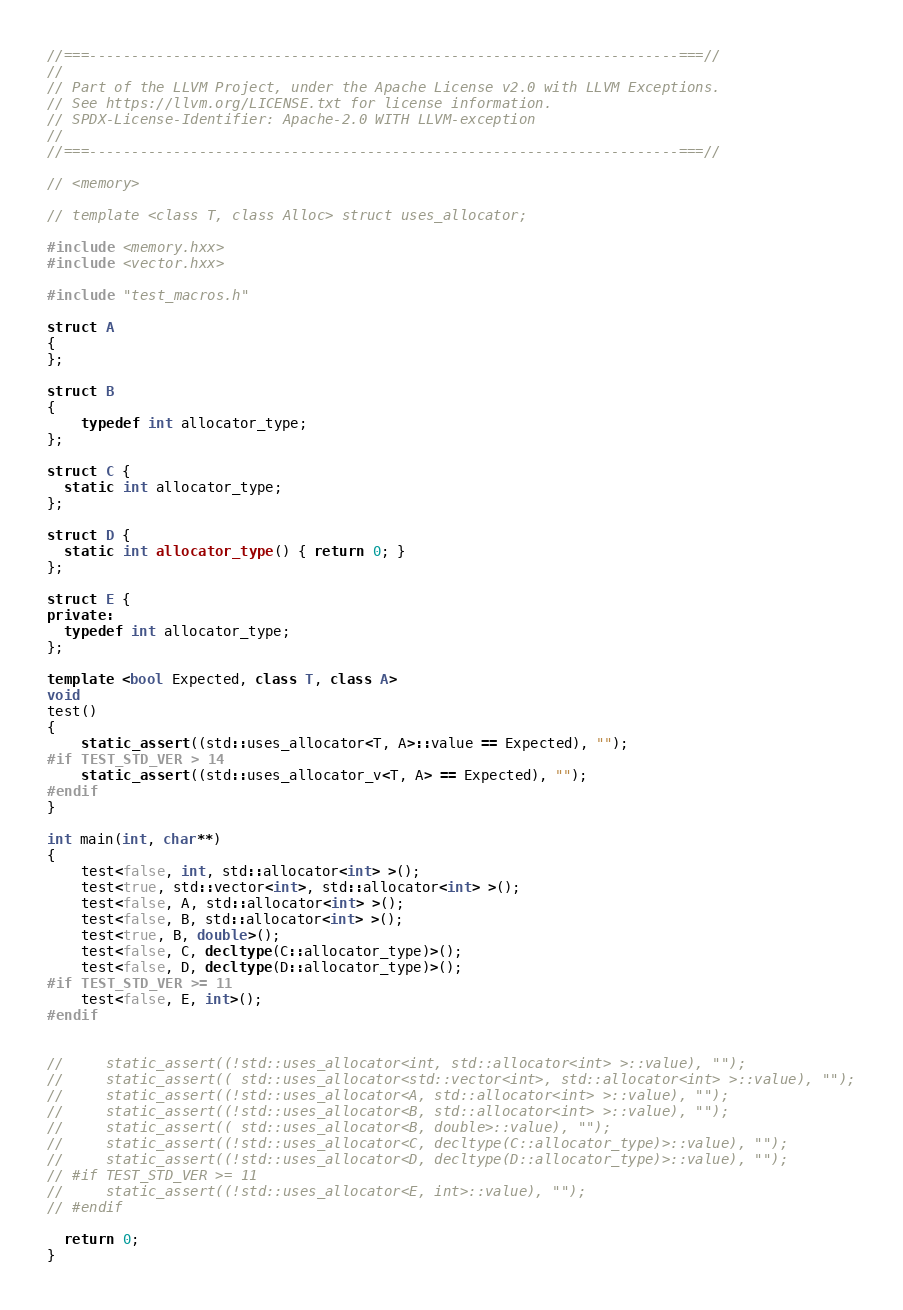<code> <loc_0><loc_0><loc_500><loc_500><_C++_>//===----------------------------------------------------------------------===//
//
// Part of the LLVM Project, under the Apache License v2.0 with LLVM Exceptions.
// See https://llvm.org/LICENSE.txt for license information.
// SPDX-License-Identifier: Apache-2.0 WITH LLVM-exception
//
//===----------------------------------------------------------------------===//

// <memory>

// template <class T, class Alloc> struct uses_allocator;

#include <memory.hxx>
#include <vector.hxx>

#include "test_macros.h"

struct A
{
};

struct B
{
    typedef int allocator_type;
};

struct C {
  static int allocator_type;
};

struct D {
  static int allocator_type() { return 0; }
};

struct E {
private:
  typedef int allocator_type;
};

template <bool Expected, class T, class A>
void
test()
{
    static_assert((std::uses_allocator<T, A>::value == Expected), "");
#if TEST_STD_VER > 14
    static_assert((std::uses_allocator_v<T, A> == Expected), "");
#endif
}

int main(int, char**)
{
    test<false, int, std::allocator<int> >();
    test<true, std::vector<int>, std::allocator<int> >();
    test<false, A, std::allocator<int> >();
    test<false, B, std::allocator<int> >();
    test<true, B, double>();
    test<false, C, decltype(C::allocator_type)>();
    test<false, D, decltype(D::allocator_type)>();
#if TEST_STD_VER >= 11
    test<false, E, int>();
#endif


//     static_assert((!std::uses_allocator<int, std::allocator<int> >::value), "");
//     static_assert(( std::uses_allocator<std::vector<int>, std::allocator<int> >::value), "");
//     static_assert((!std::uses_allocator<A, std::allocator<int> >::value), "");
//     static_assert((!std::uses_allocator<B, std::allocator<int> >::value), "");
//     static_assert(( std::uses_allocator<B, double>::value), "");
//     static_assert((!std::uses_allocator<C, decltype(C::allocator_type)>::value), "");
//     static_assert((!std::uses_allocator<D, decltype(D::allocator_type)>::value), "");
// #if TEST_STD_VER >= 11
//     static_assert((!std::uses_allocator<E, int>::value), "");
// #endif

  return 0;
}
</code> 